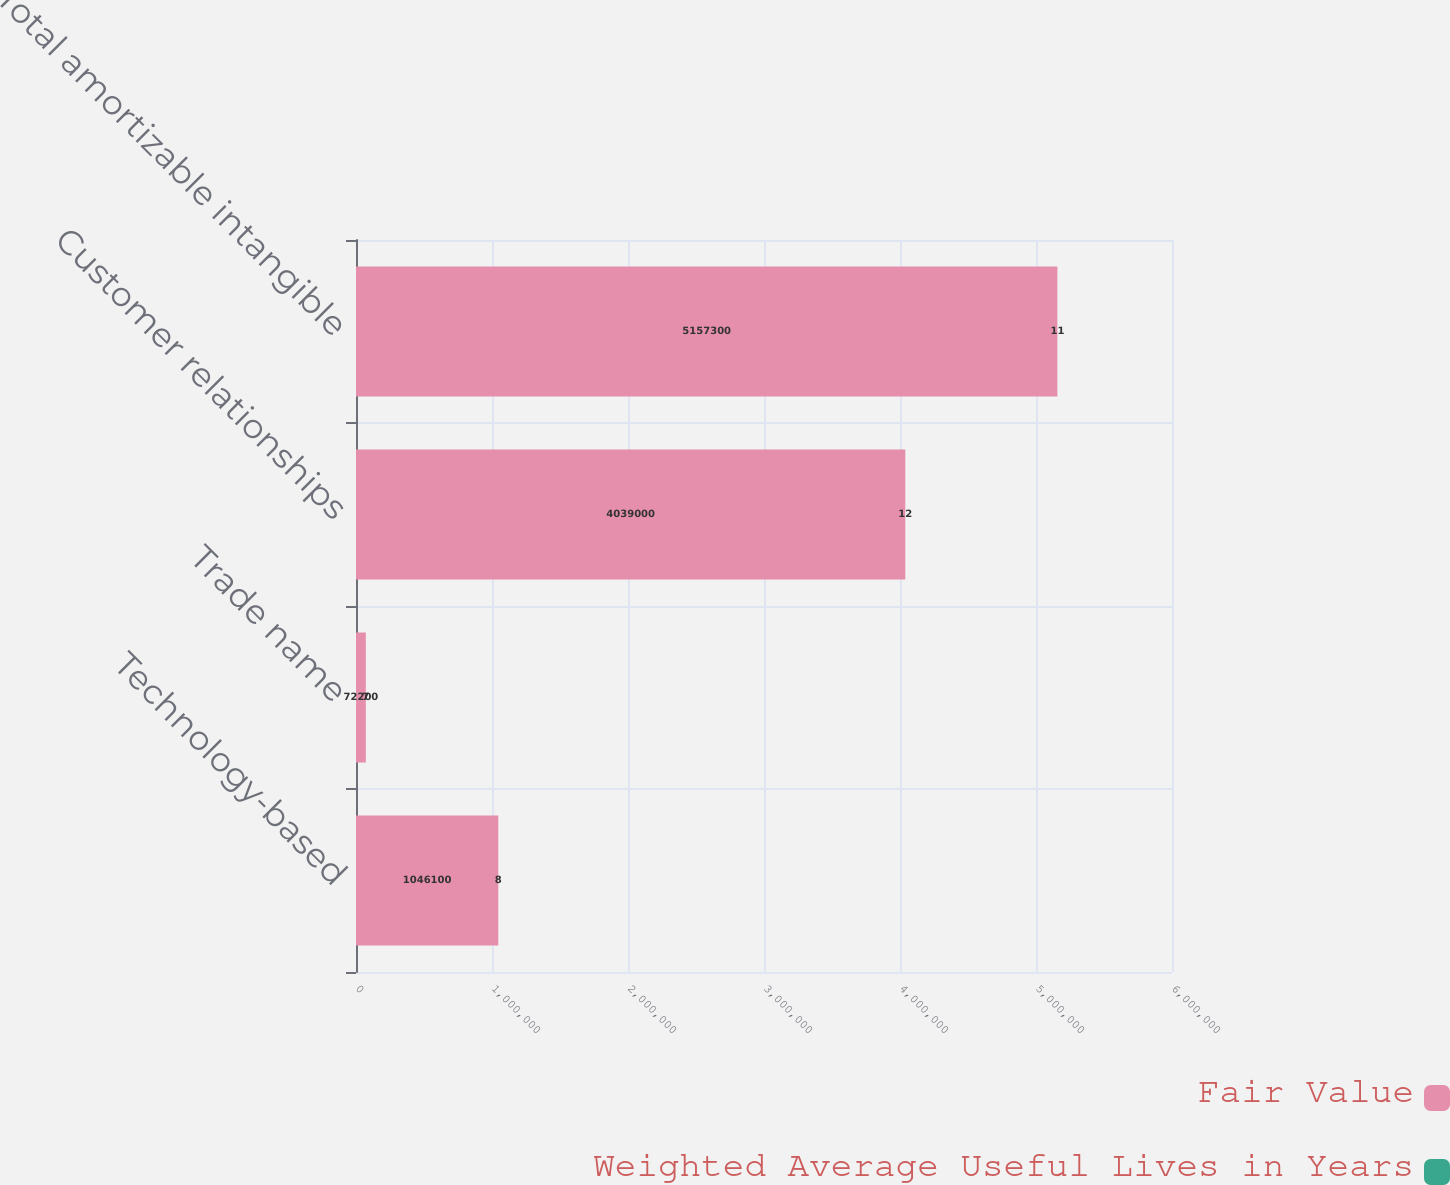<chart> <loc_0><loc_0><loc_500><loc_500><stacked_bar_chart><ecel><fcel>Technology-based<fcel>Trade name<fcel>Customer relationships<fcel>Total amortizable intangible<nl><fcel>Fair Value<fcel>1.0461e+06<fcel>72200<fcel>4.039e+06<fcel>5.1573e+06<nl><fcel>Weighted Average Useful Lives in Years<fcel>8<fcel>7<fcel>12<fcel>11<nl></chart> 